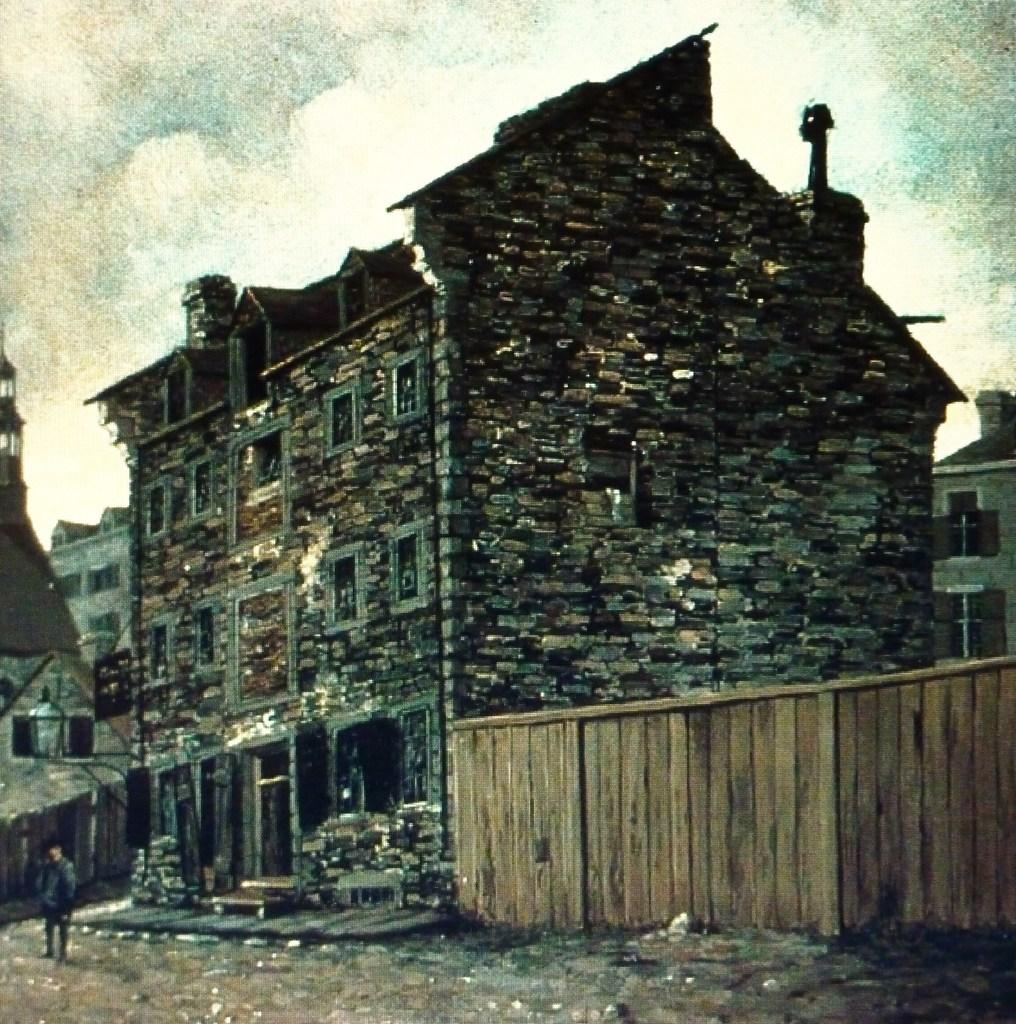What is depicted in the painting that is visible in the image? There is a painting of a building in the image. What type of structure can be seen in the image? There is a fencing in the image. Are there any people present in the image? Yes, there is a person in the image. What degree does the person in the image have? There is no information about the person's degree in the image. What type of wrist accessory is the person wearing in the image? There is no wrist accessory visible on the person in the image. 